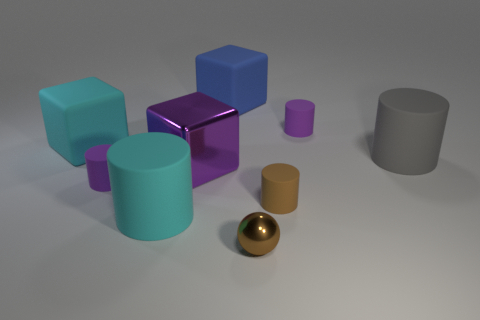How many objects are depicted in the image and can you categorize them by color? There are nine objects in the image. They can be categorized by color as follows: two turquoise objects (a cube and a cylinder), two blue blocks (one cube, one rectangular prism), one purple mirrored cube, one grey cylinder, two brown cylinders (one large, one small), and one shiny golden sphere. 